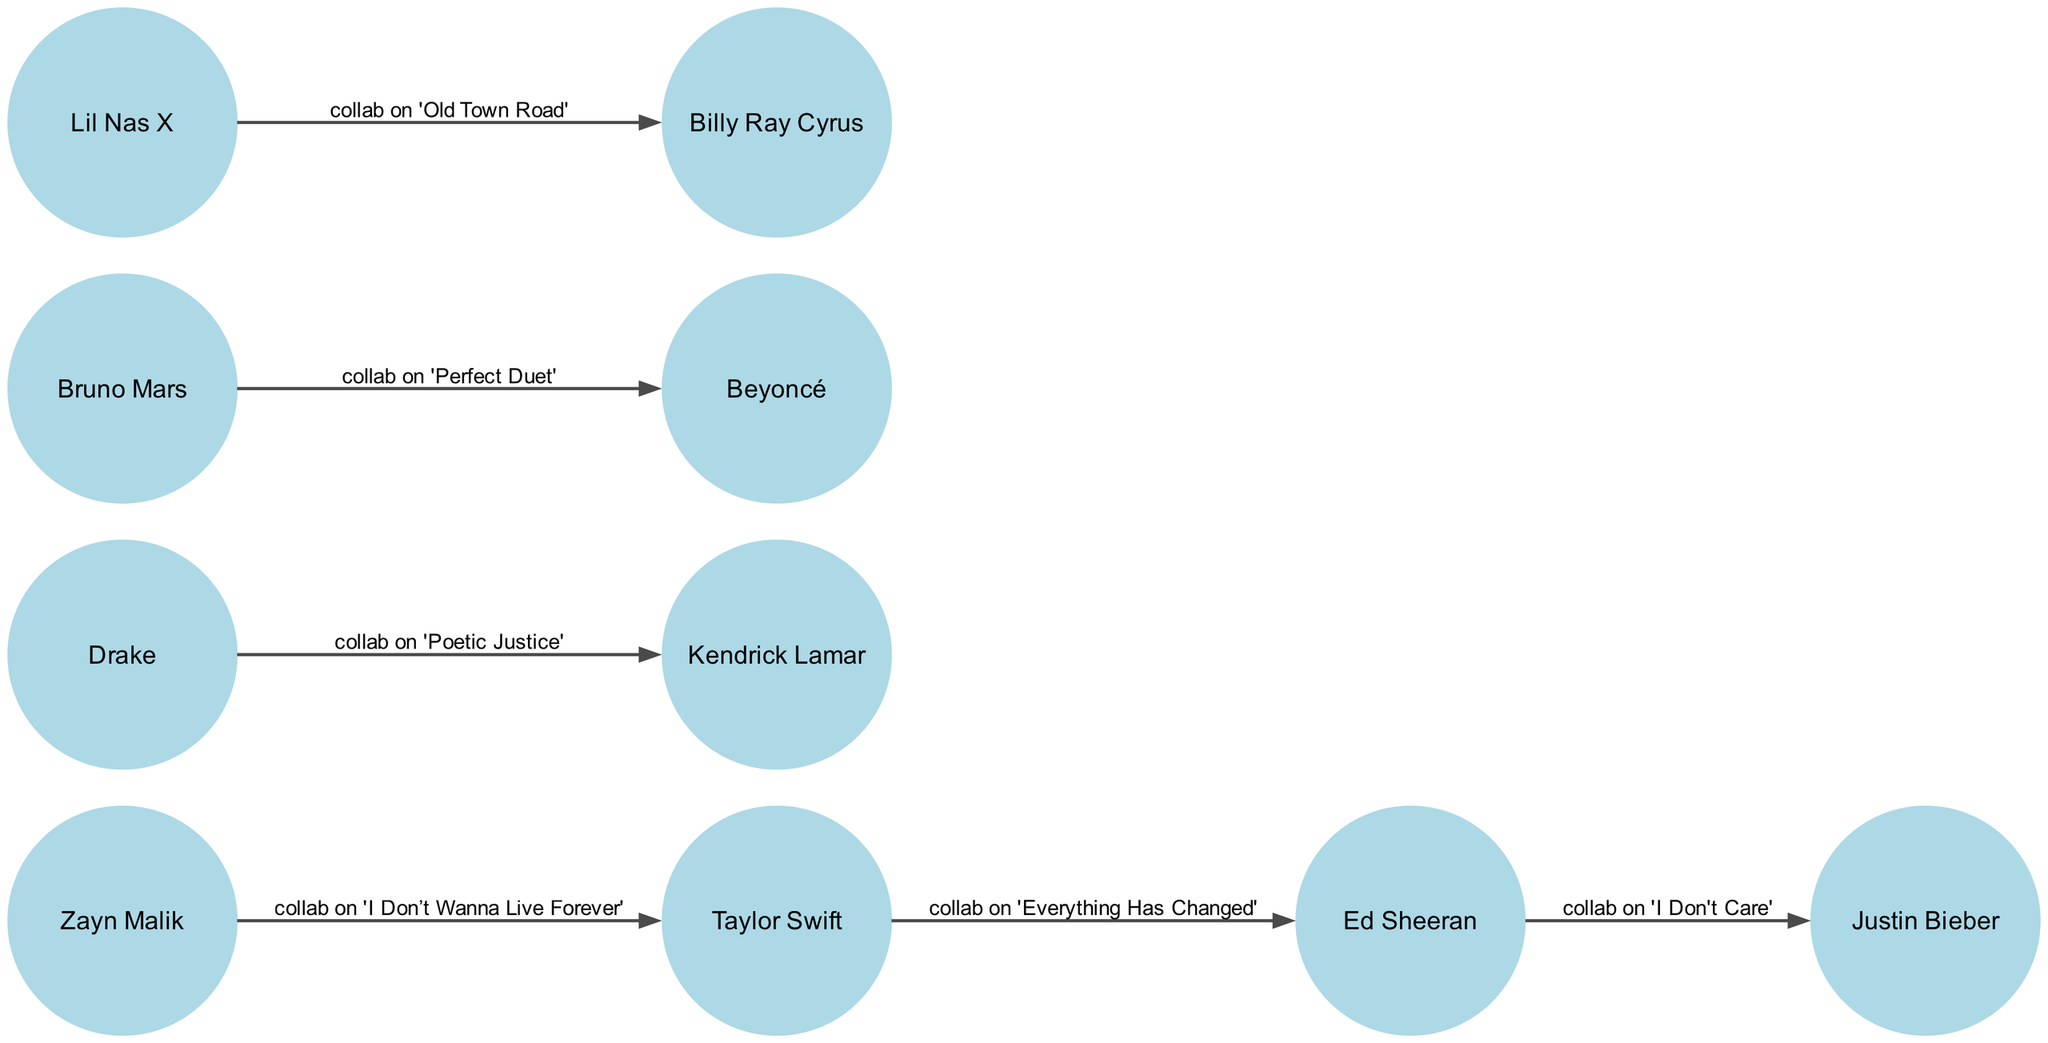What is the total number of music artists in the diagram? The diagram contains nodes representing each music artist. By counting each unique entry in the nodes section, we find there are 8 distinct artists listed.
Answer: 8 Which artist collaborated with Taylor Swift? By referring to the edges connected to Taylor Swift, we can see that there is one direct collaboration listed: Zayn Malik and Ed Sheeran. Count the edges to identify all collaborators, confirming they are connected to Taylor Swift.
Answer: Ed Sheeran, Zayn Malik What is the label of the collaboration between Drake and Kendrick Lamar? To find the answer, we look for an edge connecting Drake to Kendrick Lamar. We identify the edge in the diagram which specifies the collaboration as 'collab on Poetic Justice.'
Answer: collab on 'Poetic Justice' How many collaborations does Zayn Malik have in this diagram? Analyzing the edges for nodes connected to Zayn Malik, we observe one directed edge leading to Taylor Swift indicating a single collaboration. Hence, we can conclude the total number of collaborations Zayn Malik has is one.
Answer: 1 Which two artists collaborated on 'Perfect Duet'? To answer this, we need to look at the edge representing the collaboration. The edge exists between Bruno Mars and Beyoncé, which identifies them as the artists involved in the collaboration on 'Perfect Duet.'
Answer: Bruno Mars, Beyoncé Who has collaborated with Ed Sheeran? By examining the edges, we see that Ed Sheeran is connected to Taylor Swift and Justin Bieber. This suggests that both artists have collaborated with Ed Sheeran, as represented by the edges leading from him to these artists.
Answer: Taylor Swift, Justin Bieber Which artist has the most collaborations with the ones listed in the diagram? By analyzing all collaborations for each artist, we find that Ed Sheeran has 2 connections (to Taylor Swift and Justin Bieber), while others have either 1 or none, making him the artist with the most collaborations in the diagram.
Answer: Ed Sheeran What type of relationship does Taylor Swift have with Ed Sheeran? The relationship is specified by examining the directed edge from Taylor Swift to Ed Sheeran, which is labeled as 'collab on Everything Has Changed,' indicating a collaborative musical relationship.
Answer: collab on 'Everything Has Changed' 